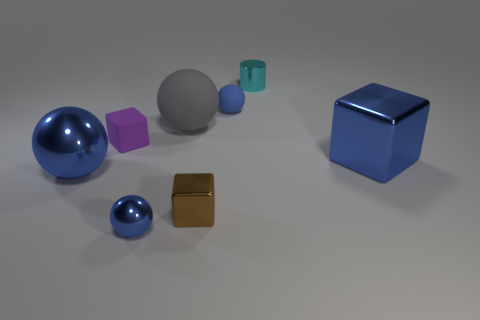Add 3 small metallic cylinders. How many small metallic cylinders exist? 4 Add 1 brown metal things. How many objects exist? 9 Subtract all brown cubes. How many cubes are left? 2 Subtract all blue metal blocks. How many blocks are left? 2 Subtract 0 gray blocks. How many objects are left? 8 Subtract all blocks. How many objects are left? 5 Subtract 3 cubes. How many cubes are left? 0 Subtract all brown spheres. Subtract all cyan cylinders. How many spheres are left? 4 Subtract all green spheres. How many cyan cubes are left? 0 Subtract all big purple matte balls. Subtract all big blue shiny things. How many objects are left? 6 